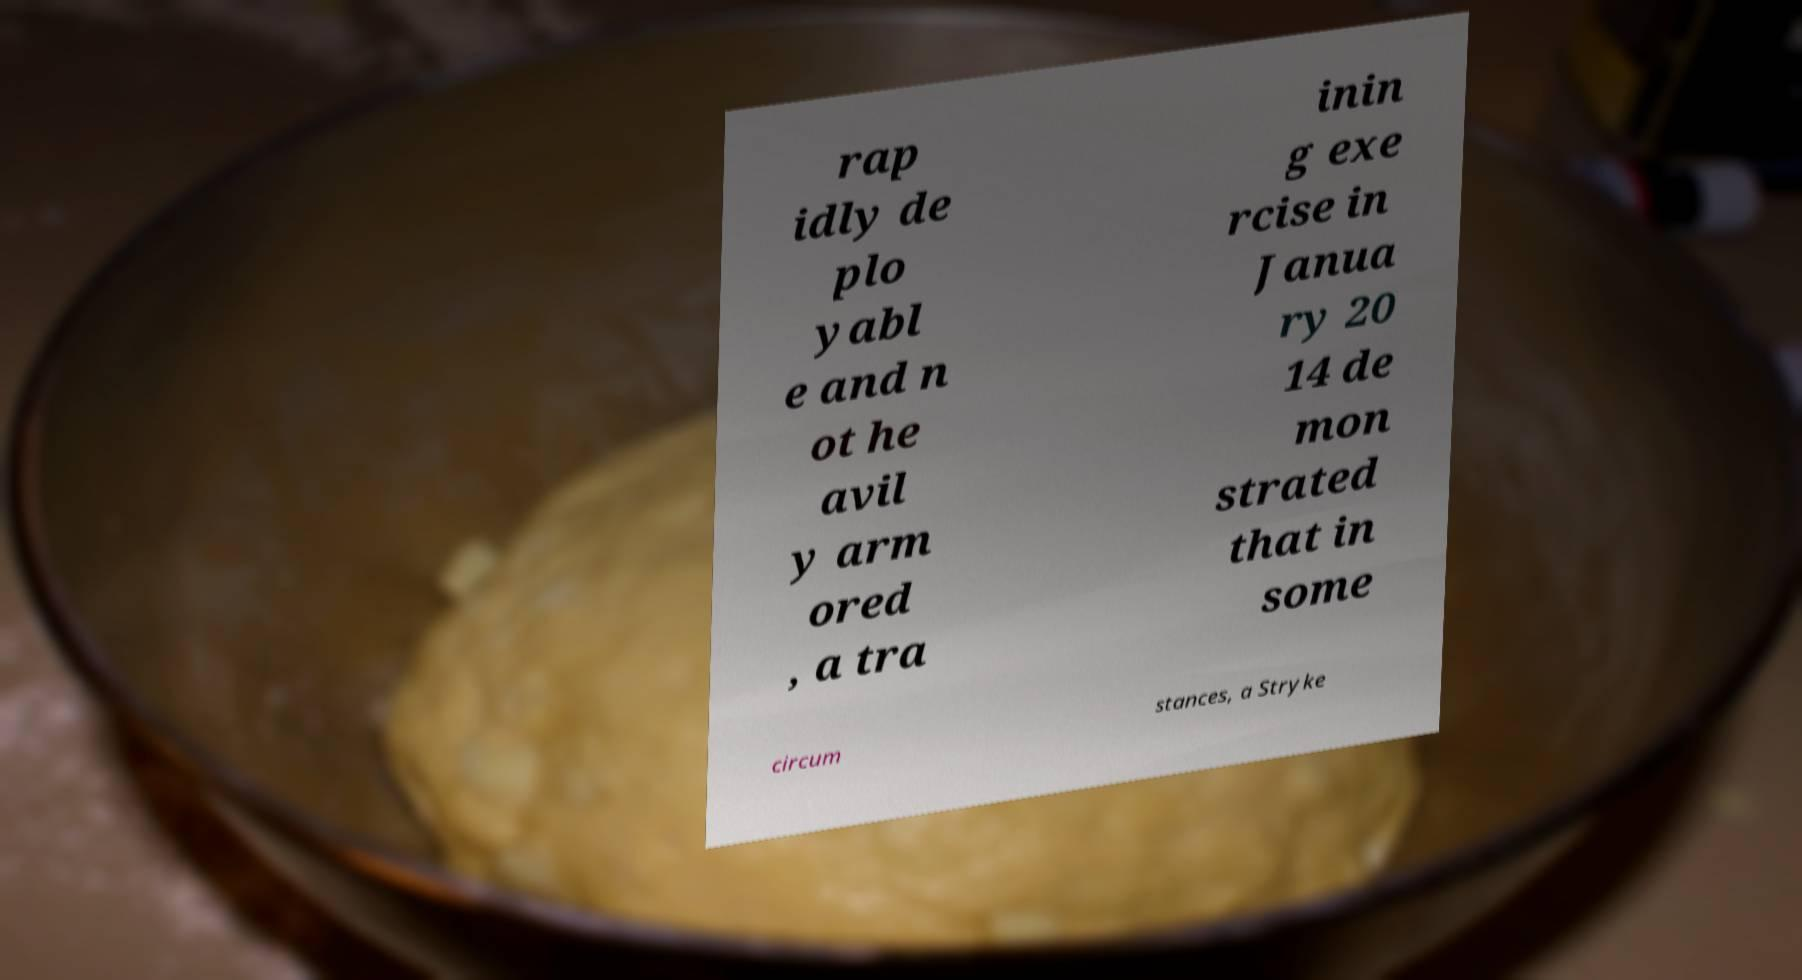Can you accurately transcribe the text from the provided image for me? rap idly de plo yabl e and n ot he avil y arm ored , a tra inin g exe rcise in Janua ry 20 14 de mon strated that in some circum stances, a Stryke 